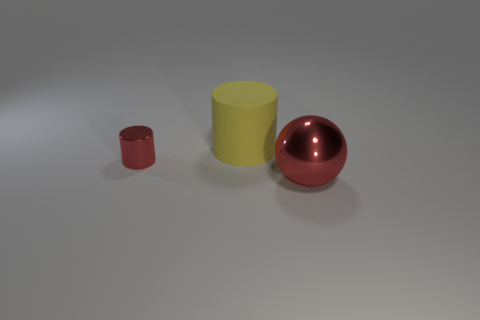There is a tiny metal thing that is the same color as the large shiny sphere; what shape is it?
Offer a terse response. Cylinder. What material is the large yellow cylinder?
Your answer should be compact. Rubber. Is there any other thing that is the same color as the rubber cylinder?
Ensure brevity in your answer.  No. Is the yellow rubber thing the same shape as the tiny shiny object?
Provide a short and direct response. Yes. There is a red object on the left side of the large thing that is behind the large object that is in front of the metallic cylinder; how big is it?
Give a very brief answer. Small. What number of other objects are the same material as the yellow cylinder?
Keep it short and to the point. 0. There is a cylinder that is behind the small red cylinder; what color is it?
Your response must be concise. Yellow. What is the material of the cylinder behind the red thing that is on the left side of the big object behind the red shiny sphere?
Your answer should be very brief. Rubber. Is there another thing of the same shape as the small red thing?
Ensure brevity in your answer.  Yes. What shape is the yellow object that is the same size as the ball?
Your response must be concise. Cylinder. 